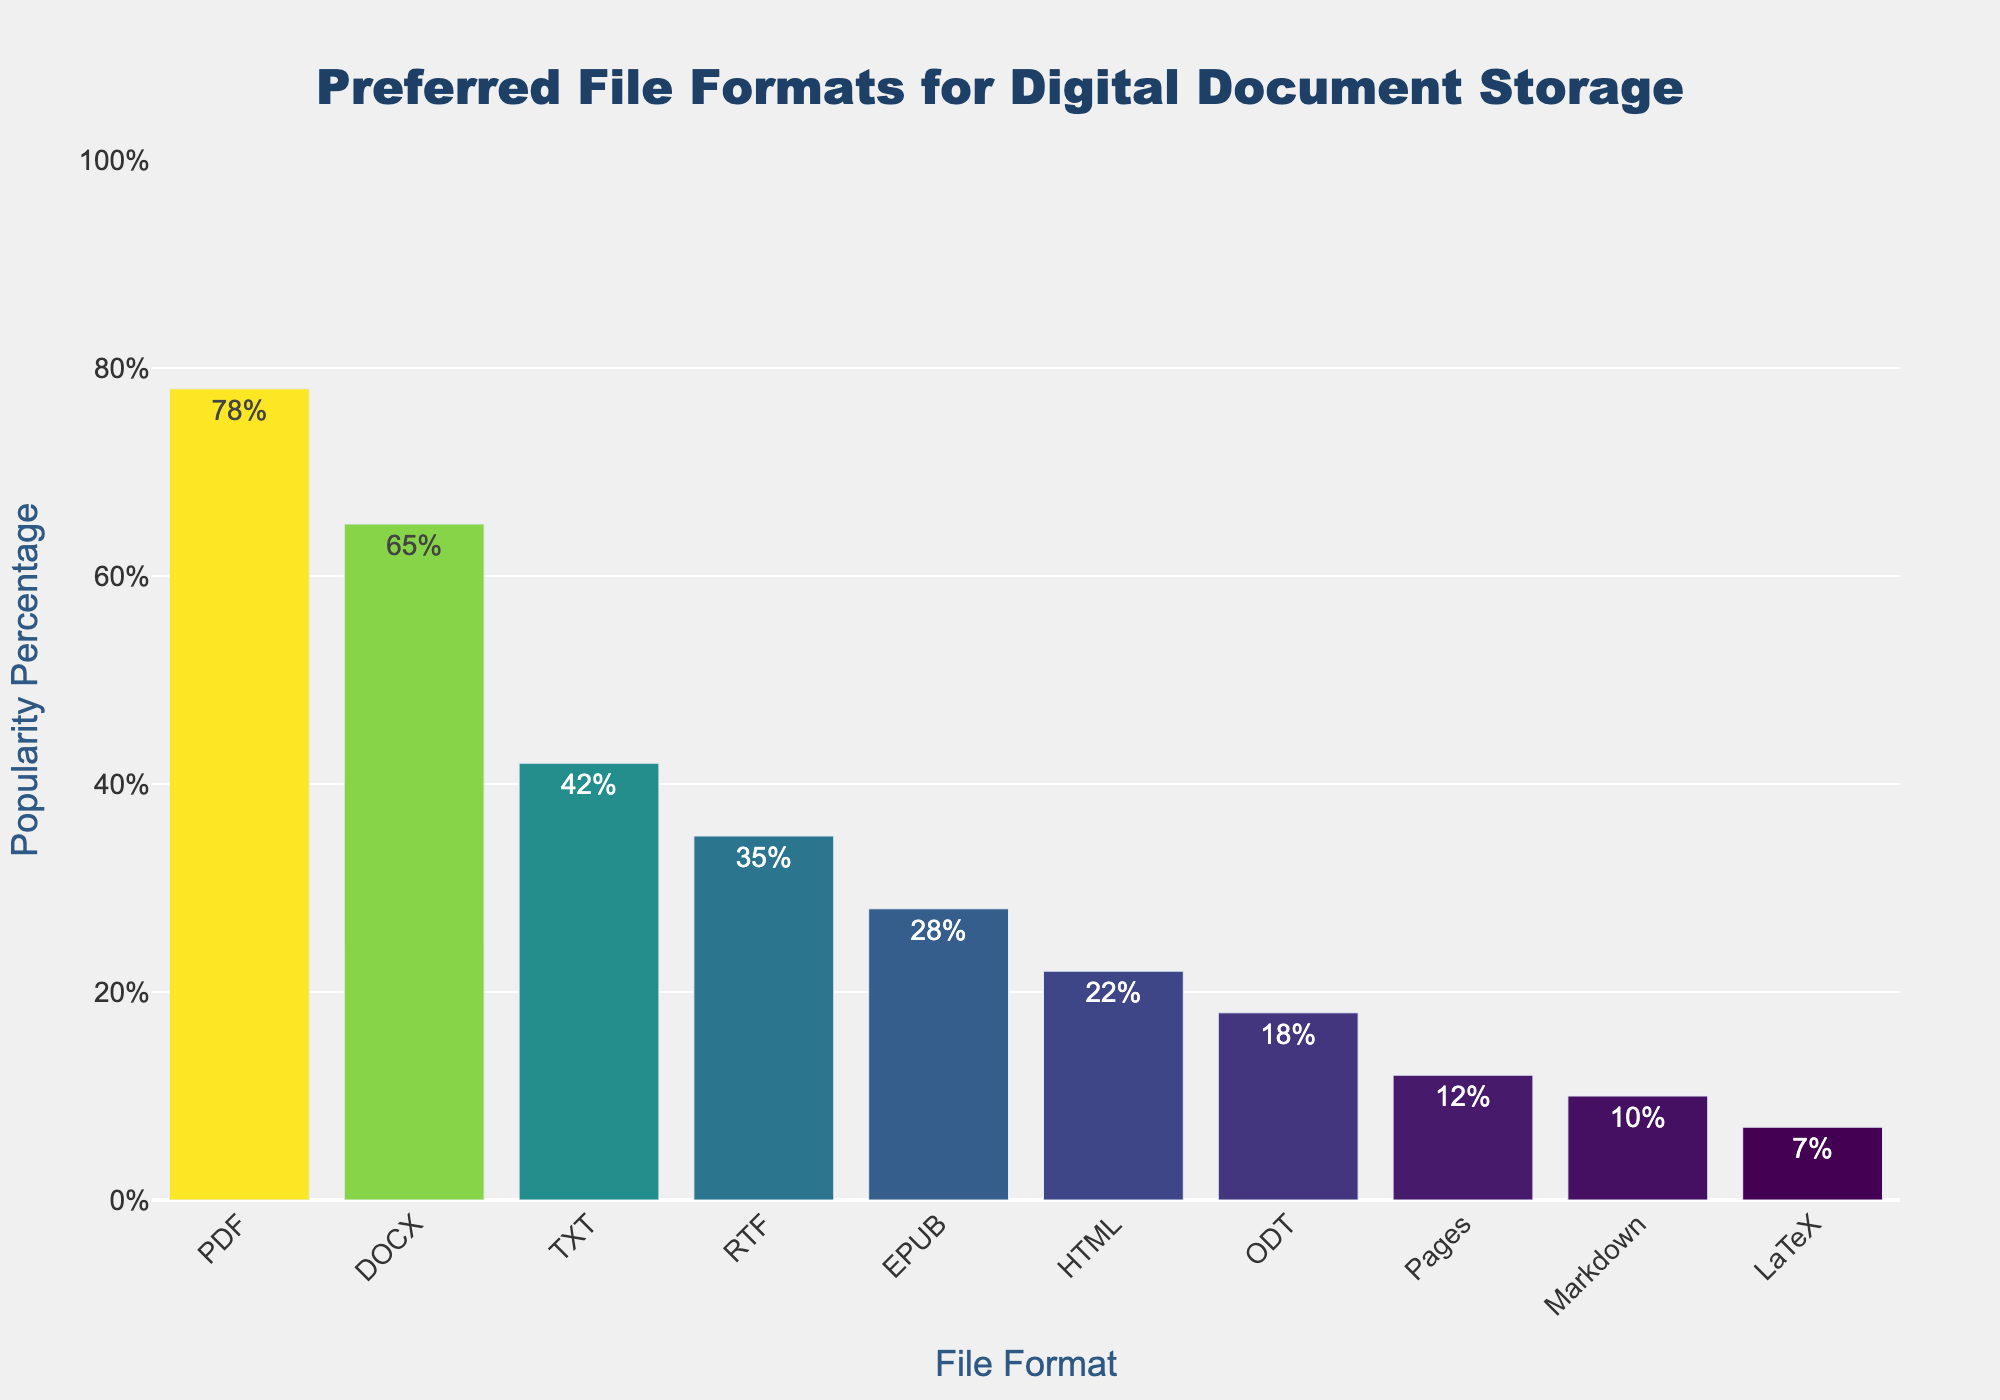what's the most popular file format for digital document storage among freelance writers? To determine the most popular file format, look for the bar with the highest height. The bar labeled 'PDF' clearly stands out as the tallest one, indicating the highest popularity percentage.
Answer: PDF Which file formats have a popularity percentage greater than 50%? To find file formats with a popularity greater than 50%, identify the bars that extend above the 50% mark on the y-axis. The bars labeled 'PDF' and 'DOCX' exceed this value.
Answer: PDF, DOCX What is the sum of the popularity percentages of PDF, DOCX, and TXT? Add the percentages of the specified file formats: PDF (78%), DOCX (65%), and TXT (42%). The sum is 78 + 65 + 42 = 185.
Answer: 185% How much more popular is PDF compared to EPUB? Subtract the popularity percentage of EPUB from that of PDF: 78% - 28% = 50%. This shows that PDF is 50% more popular than EPUB.
Answer: 50% Which file format has a popularity percentage closest to 20%? Compare the popularity percentages to find the value closest to 20%. The file format HTML has a popularity of 22%, which is nearest to 20%.
Answer: HTML What is the average popularity percentage of RTF, EPUB, HTML, and ODT? Calculate the average by summing the percentages and dividing by the number of file formats: (35% + 28% + 22% + 18%) / 4 = 103 / 4 = 25.75%.
Answer: 25.75% Is the popularity percentage of Markdown greater or less than that of Pages? Compare the heights of the bars for Markdown and Pages. Markdown has 10%, whereas Pages has 12%, indicating that Markdown is less popular than Pages.
Answer: Less How does the popularity of LaTeX compare to the average popularity of all other listed file formats? First, calculate the average percentage of all file formats excluding LaTeX. Sum the percentages of all other file formats (totaling 345%) and divide by 9 (since there are 9 other formats): 345 / 9 = 38.33%. Comparing this to LaTeX's popularity of 7%, LaTeX is significantly below the average.
Answer: Below the average Which file formats have a popularity percentage less than 20%? Identify the bars with heights below the 20% mark on the y-axis. The file formats with less than 20% popularity are ODT (18%), Pages (12%), Markdown (10%), and LaTeX (7%).
Answer: ODT, Pages, Markdown, LaTeX What is the difference between the popularity of the most and least popular file formats? Subtract the popularity percentage of the least popular format (LaTeX, 7%) from that of the most popular format (PDF, 78%): 78% - 7% = 71%.
Answer: 71% 